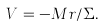Convert formula to latex. <formula><loc_0><loc_0><loc_500><loc_500>V = - M r / \Sigma .</formula> 